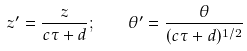<formula> <loc_0><loc_0><loc_500><loc_500>z ^ { \prime } = \frac { z } { c \tau + d } ; \quad \theta ^ { \prime } = \frac { \theta } { ( c \tau + d ) ^ { 1 / 2 } }</formula> 